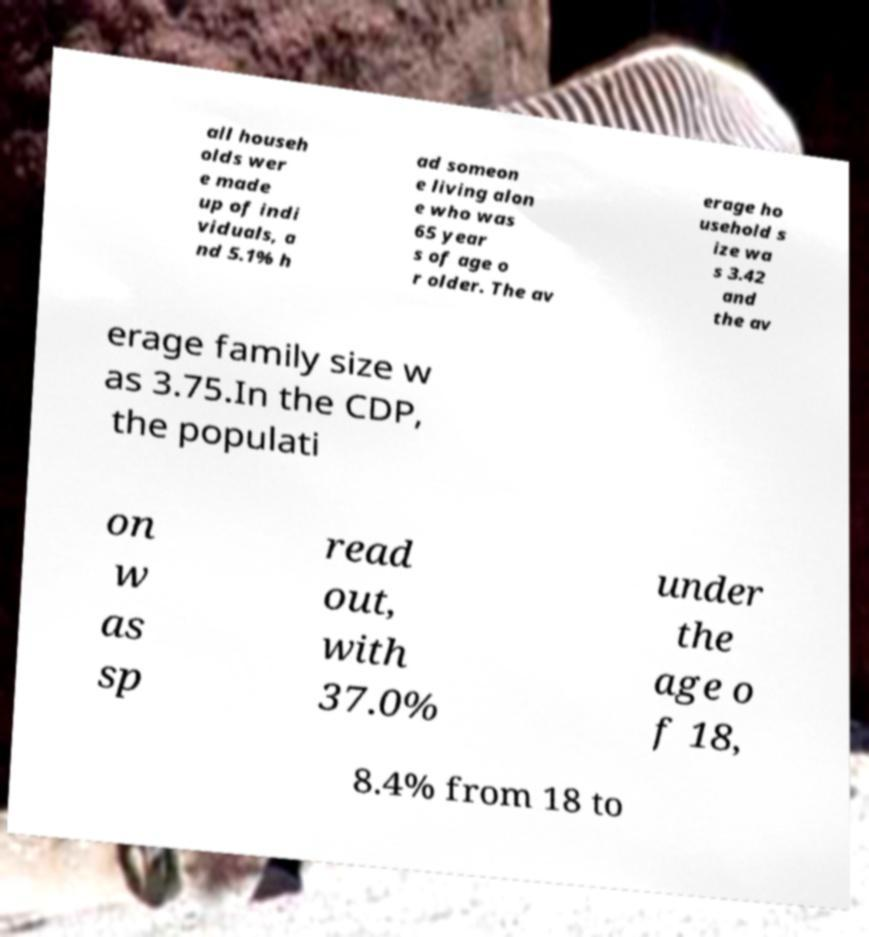For documentation purposes, I need the text within this image transcribed. Could you provide that? all househ olds wer e made up of indi viduals, a nd 5.1% h ad someon e living alon e who was 65 year s of age o r older. The av erage ho usehold s ize wa s 3.42 and the av erage family size w as 3.75.In the CDP, the populati on w as sp read out, with 37.0% under the age o f 18, 8.4% from 18 to 